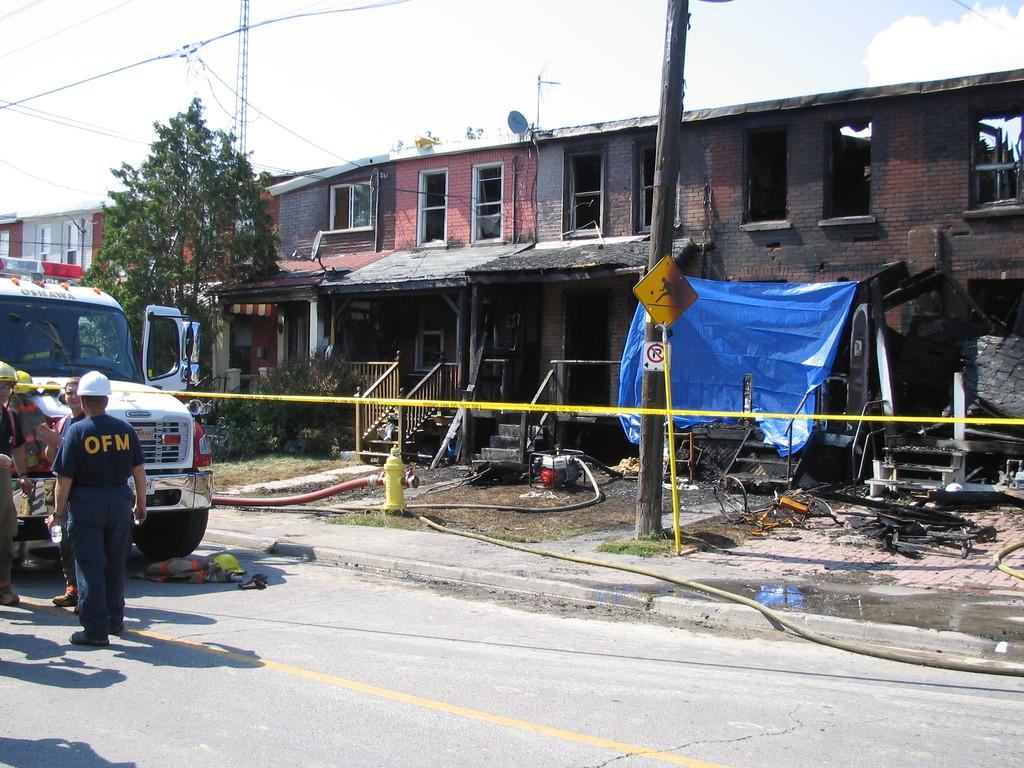What type of structures can be seen in the image? There are buildings in the image. What architectural features are visible in the image? There are windows, stairs, and a pole in the image. What natural elements are present in the image? There are trees in the image. Are there any people in the image? Yes, there are people in the image. What type of utility infrastructure is visible in the image? There are pipes and a fire hydrant in the image. What mode of transportation is present in the image? There is a vehicle in the image. What type of signage is visible in the image? There are sign boards in the image. What color is the sky in the image? The sky is white in color. What type of cover is present in the image? There is a blue cover in the image. What type of butter is being used for arithmetic in the image? There is no butter or arithmetic present in the image. What type of pleasure can be seen on the faces of the people in the image? The image does not provide information about the emotions or pleasure of the people present. 